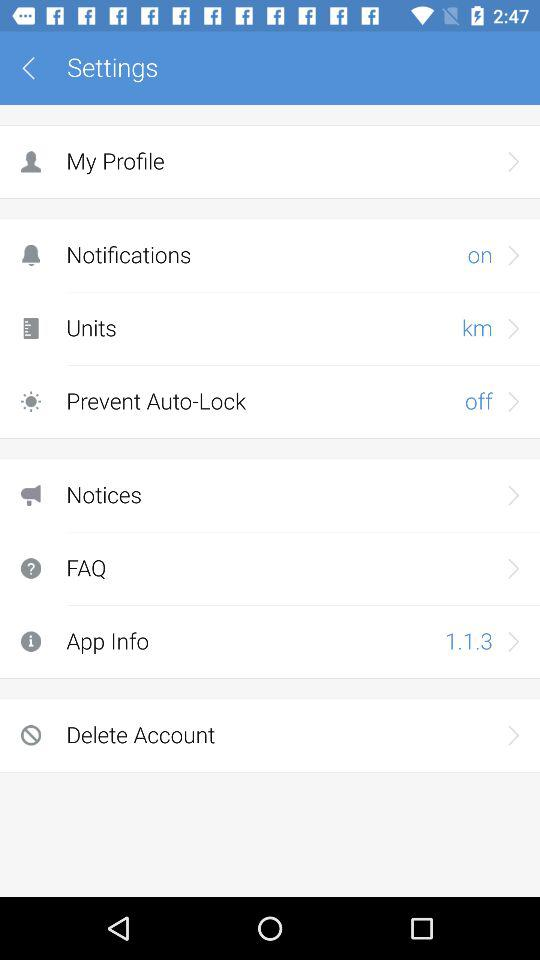What is the unit? The unit is km. 